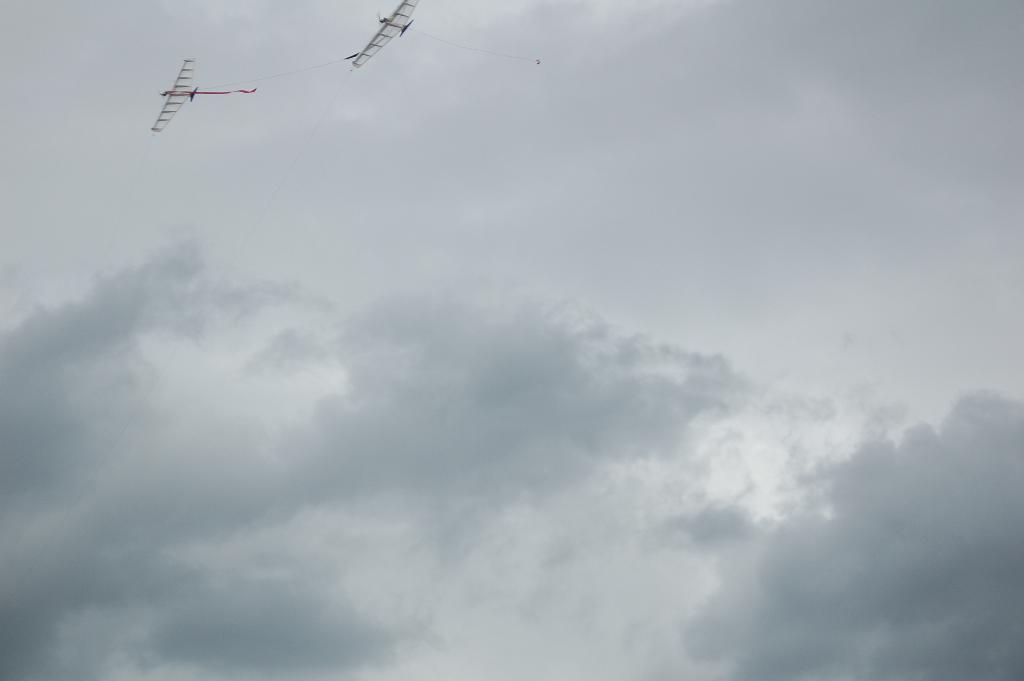Could you give a brief overview of what you see in this image? In this picture, they are looking like kites and the kites flying in the sky. 